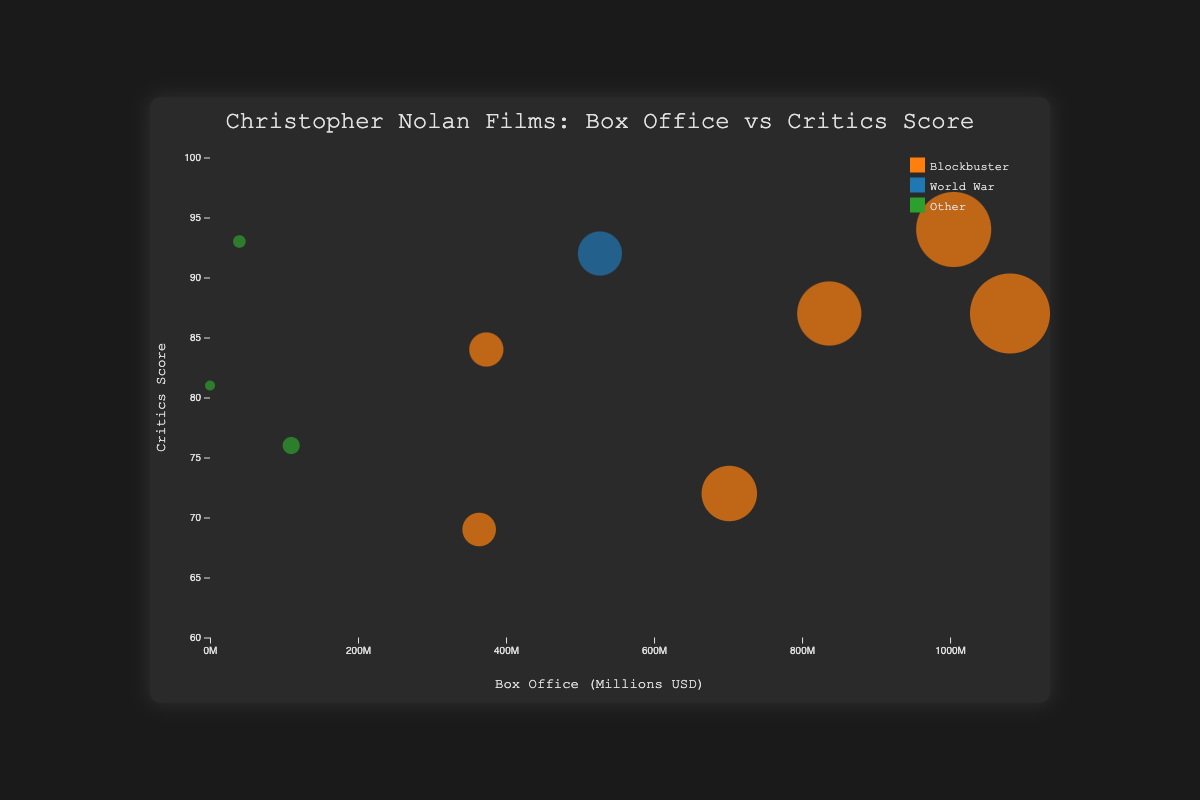How many films are represented in the bubble chart? By counting the number of data points, or bubbles, visible on the chart, you can determine the number of films.
Answer: 10 What is the title of the bubble chart? The title can be found at the top center of the chart in larger font size.
Answer: Christopher Nolan Films: Box Office vs Critics Score Which Nolan movie has the highest box office earnings? By identifying the bubble farthest to the right on the x-axis (Box Office in millions), you can determine the highest-grossing film.
Answer: The Dark Knight Rises Between 'Inception' and 'Dunkirk', which film has a higher critics score? Locate the bubbles for 'Inception' and 'Dunkirk' and compare their positions on the y-axis to determine the higher critics score.
Answer: Dunkirk What is the approximate box office difference between 'Tenet' and 'Memento'? Find the x-axis positions of 'Tenet' and 'Memento' and calculate their difference by subtraction.
Answer: Approximately 324 million USD What color is used to represent World War films? The legend in the chart indicates the colors for "Blockbuster," "World War," and "Other" categories.
Answer: Blue Which film has both low box office earnings and a very high critics score? Identify the bubble positioned low on the x-axis (box office earnings) and high on the y-axis (critics score).
Answer: Memento What is the average critics score of Nolan's Blockbuster films? By examining each bubble labeled as a "Blockbuster" in the legend and summing their critics scores, then dividing by the number of those films.
Answer: (87 + 72 + 94 + 87 + 69 + 84) / 6 = 82.17 Is there any film that is neither a blockbuster nor a World War film but still has a high critics score? Identify the green bubbles (representing "Other" films) positioned high on the y-axis.
Answer: Memento Do films with higher box office earnings generally have higher critics scores in this chart? By visually examining the distribution of bubbles from left to right and from bottom to top, you can infer if there's a positive trend between box office earnings and critics scores.
Answer: Not necessarily 